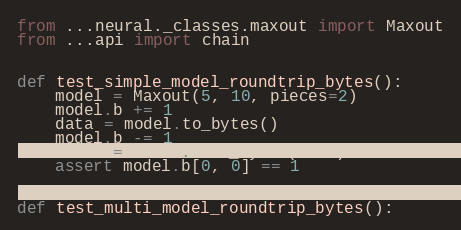Convert code to text. <code><loc_0><loc_0><loc_500><loc_500><_Python_>from ...neural._classes.maxout import Maxout
from ...api import chain


def test_simple_model_roundtrip_bytes():
    model = Maxout(5, 10, pieces=2)
    model.b += 1
    data = model.to_bytes()
    model.b -= 1
    model = model.from_bytes(data)
    assert model.b[0, 0] == 1


def test_multi_model_roundtrip_bytes():</code> 